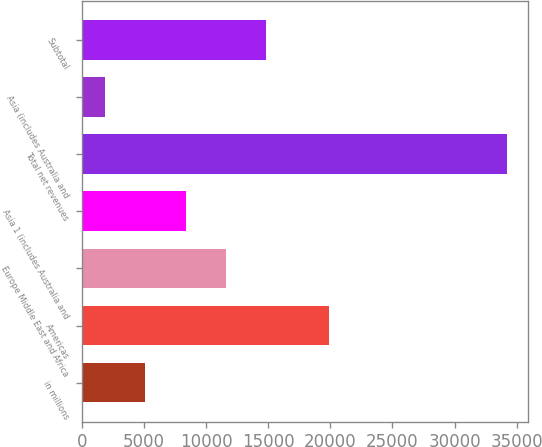Convert chart to OTSL. <chart><loc_0><loc_0><loc_500><loc_500><bar_chart><fcel>in millions<fcel>Americas<fcel>Europe Middle East and Africa<fcel>Asia 1 (includes Australia and<fcel>Total net revenues<fcel>Asia (includes Australia and<fcel>Subtotal<nl><fcel>5112.6<fcel>19858<fcel>11577.8<fcel>8345.2<fcel>34206<fcel>1880<fcel>14810.4<nl></chart> 